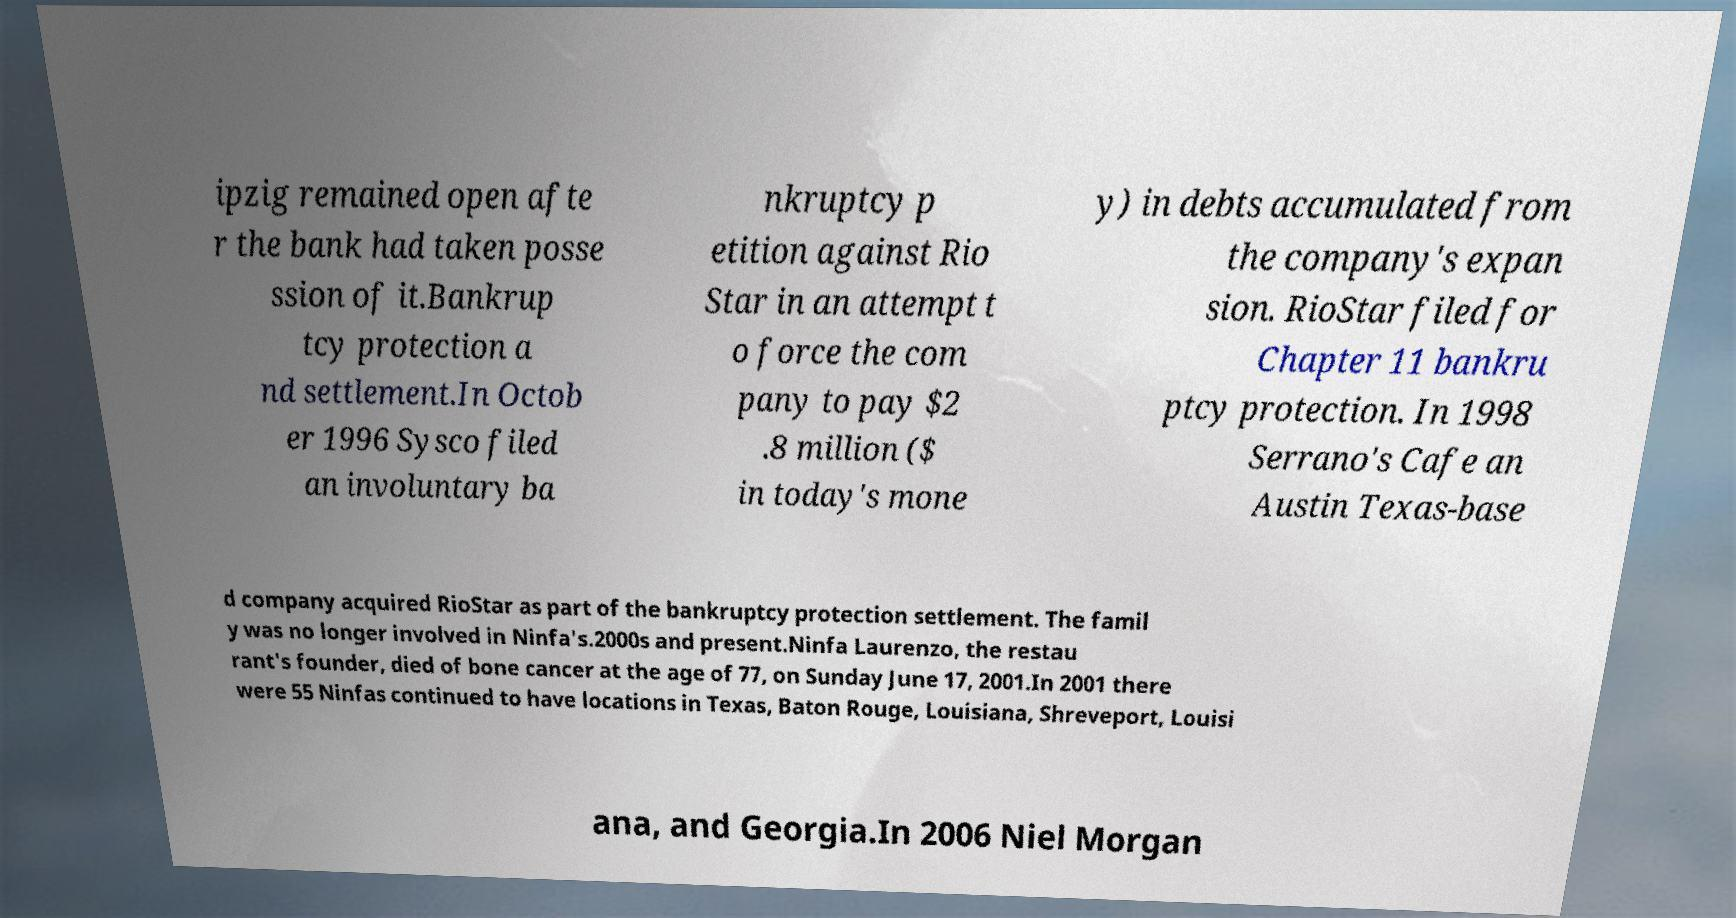Could you assist in decoding the text presented in this image and type it out clearly? ipzig remained open afte r the bank had taken posse ssion of it.Bankrup tcy protection a nd settlement.In Octob er 1996 Sysco filed an involuntary ba nkruptcy p etition against Rio Star in an attempt t o force the com pany to pay $2 .8 million ($ in today's mone y) in debts accumulated from the company's expan sion. RioStar filed for Chapter 11 bankru ptcy protection. In 1998 Serrano's Cafe an Austin Texas-base d company acquired RioStar as part of the bankruptcy protection settlement. The famil y was no longer involved in Ninfa's.2000s and present.Ninfa Laurenzo, the restau rant's founder, died of bone cancer at the age of 77, on Sunday June 17, 2001.In 2001 there were 55 Ninfas continued to have locations in Texas, Baton Rouge, Louisiana, Shreveport, Louisi ana, and Georgia.In 2006 Niel Morgan 